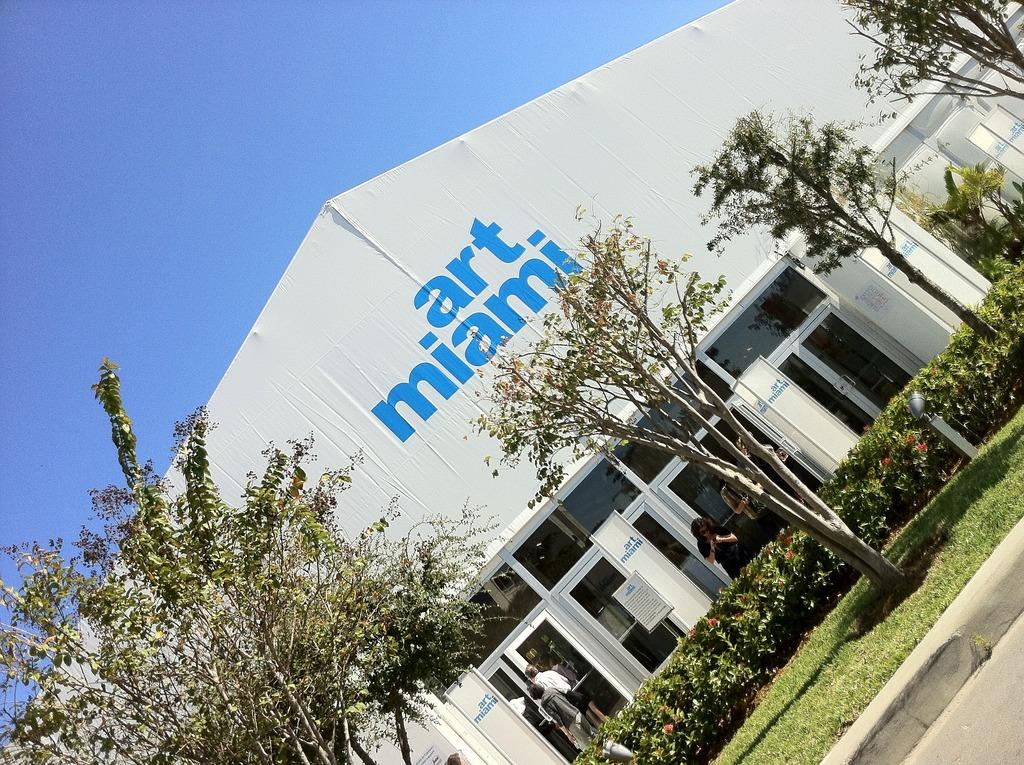What type of structure is present in the image? There is a building in the image. Are there any people visible in the image? Yes, there are people standing in the image. What type of entrance can be seen in the building? There is a glass door in the image. What type of natural environment is visible in the image? There are trees in the image. What is visible above the building and trees? The sky is visible in the image. Can you see anyone swimming in the image? There is no swimming activity depicted in the image. 